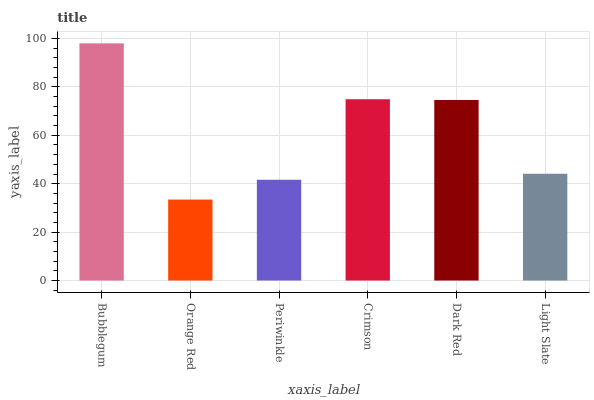Is Orange Red the minimum?
Answer yes or no. Yes. Is Bubblegum the maximum?
Answer yes or no. Yes. Is Periwinkle the minimum?
Answer yes or no. No. Is Periwinkle the maximum?
Answer yes or no. No. Is Periwinkle greater than Orange Red?
Answer yes or no. Yes. Is Orange Red less than Periwinkle?
Answer yes or no. Yes. Is Orange Red greater than Periwinkle?
Answer yes or no. No. Is Periwinkle less than Orange Red?
Answer yes or no. No. Is Dark Red the high median?
Answer yes or no. Yes. Is Light Slate the low median?
Answer yes or no. Yes. Is Crimson the high median?
Answer yes or no. No. Is Crimson the low median?
Answer yes or no. No. 